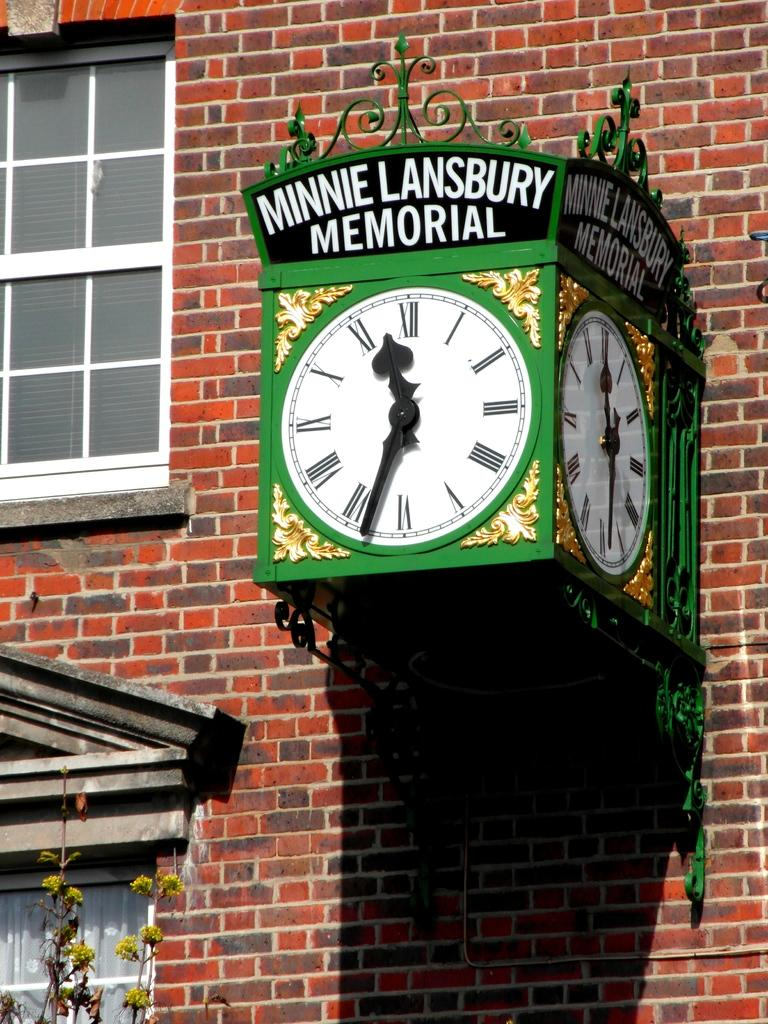<image>
Relay a brief, clear account of the picture shown. A green clock reading "Minnie Lansubury Memorial" sticks out of a brick building. 